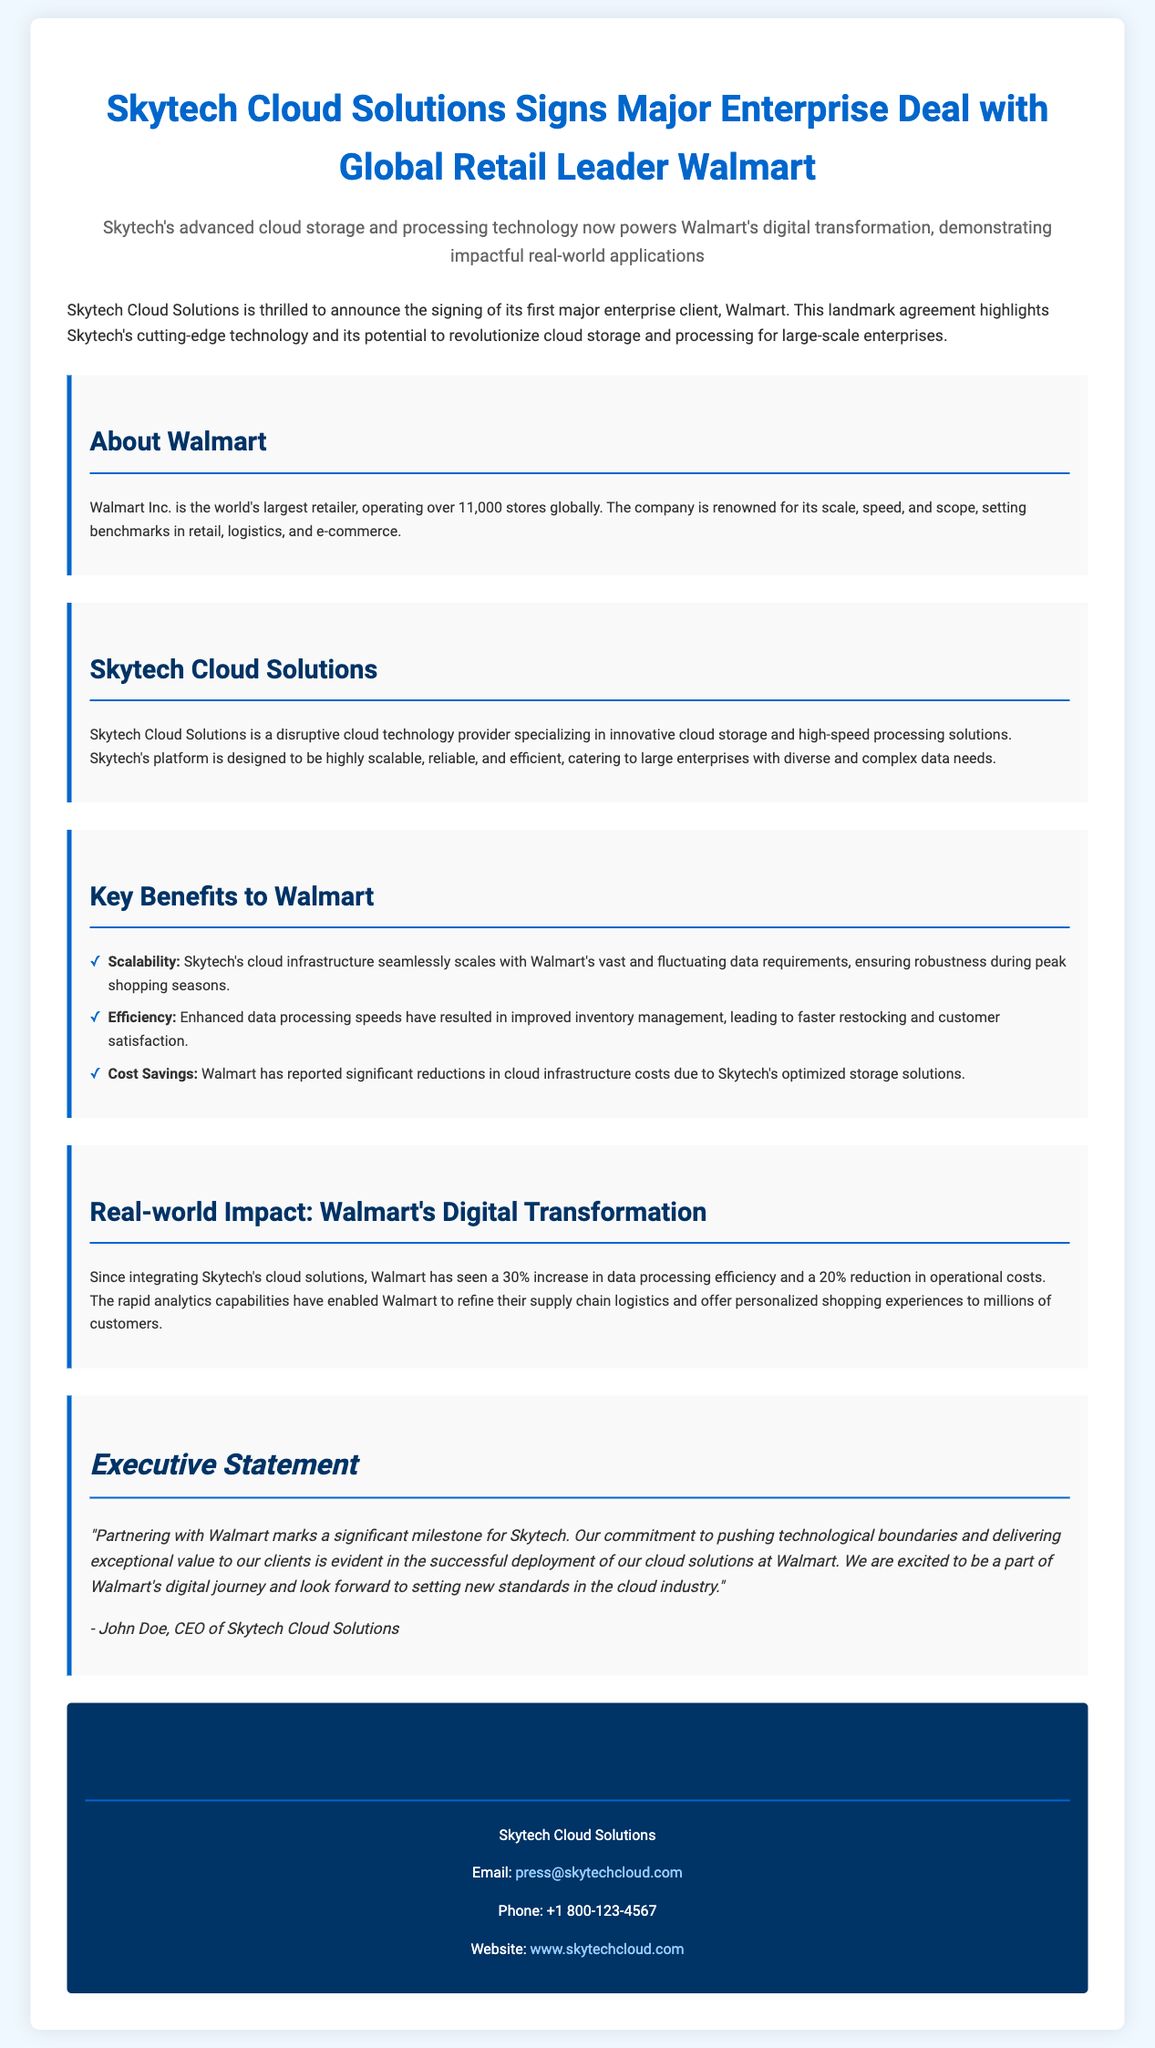What is the name of the client Skytech signed? The press release states that Walmart is the first major enterprise client Skytech has signed.
Answer: Walmart What is the main technology provided by Skytech? The document mentions that Skytech specializes in innovative cloud storage and high-speed processing solutions.
Answer: Cloud storage and high-speed processing What percentage increase in data processing efficiency did Walmart experience? The release indicates that Walmart saw a 30% increase in data processing efficiency since integrating Skytech's solutions.
Answer: 30% Who is the CEO of Skytech Cloud Solutions? The executive statement credits John Doe as the CEO of Skytech Cloud Solutions.
Answer: John Doe What are the three key benefits to Walmart mentioned? The benefits listed include scalability, efficiency, and cost savings.
Answer: Scalability, efficiency, cost savings How many stores does Walmart operate globally? The document specifies that Walmart operates over 11,000 stores worldwide.
Answer: Over 11,000 What has Walmart reported regarding cloud infrastructure costs? Walmart has reported significant reductions in cloud infrastructure costs due to Skytech's solutions.
Answer: Significant reductions What is the purpose of this press release? The document announces the signing of Walmart as a major enterprise client and highlights the impact of Skytech's technology.
Answer: Announce Walmart partnership and technology impact 